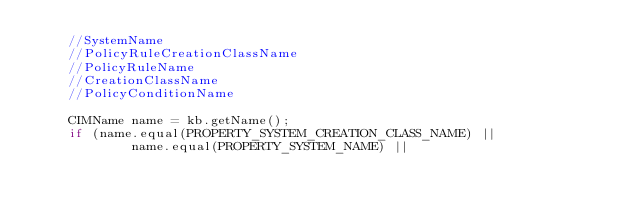Convert code to text. <code><loc_0><loc_0><loc_500><loc_500><_C++_>	//SystemName
	//PolicyRuleCreationClassName
	//PolicyRuleName
	//CreationClassName
	//PolicyConditionName

	CIMName name = kb.getName();
	if (name.equal(PROPERTY_SYSTEM_CREATION_CLASS_NAME) ||
			name.equal(PROPERTY_SYSTEM_NAME) ||</code> 